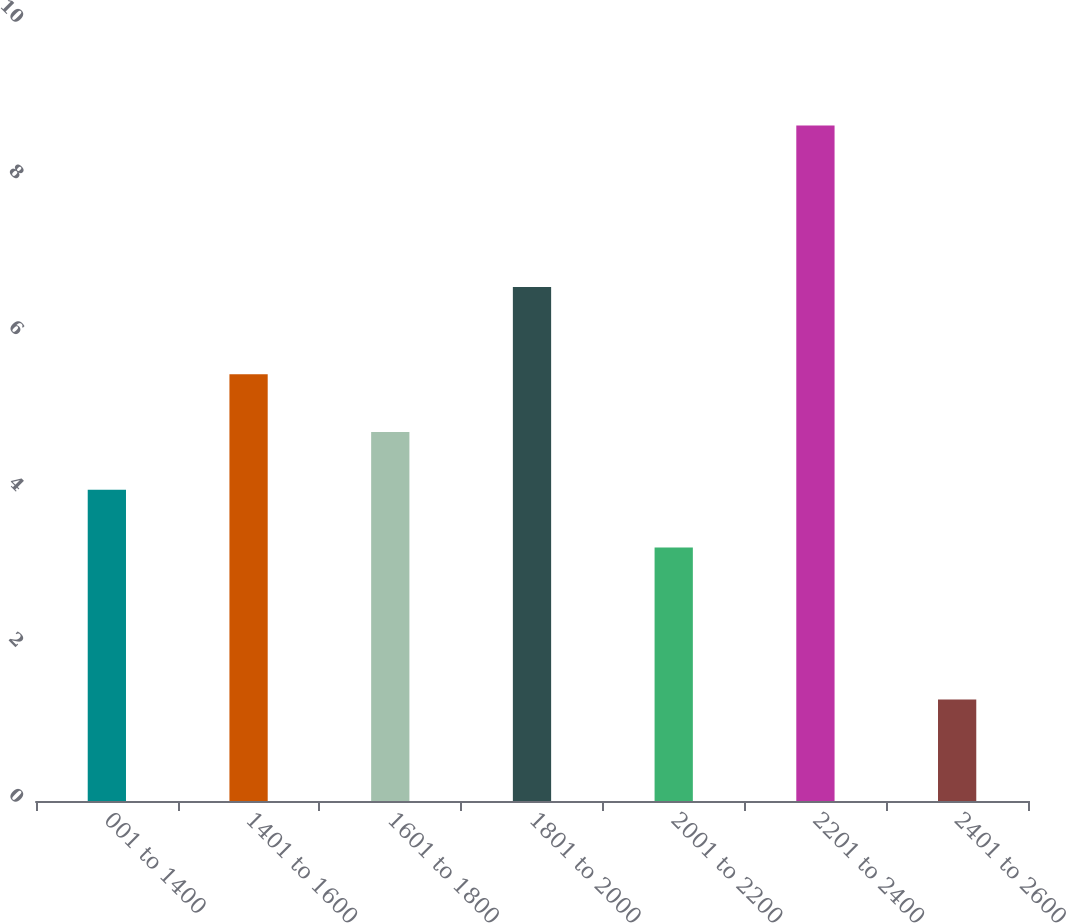Convert chart. <chart><loc_0><loc_0><loc_500><loc_500><bar_chart><fcel>001 to 1400<fcel>1401 to 1600<fcel>1601 to 1800<fcel>1801 to 2000<fcel>2001 to 2200<fcel>2201 to 2400<fcel>2401 to 2600<nl><fcel>3.99<fcel>5.47<fcel>4.73<fcel>6.59<fcel>3.25<fcel>8.66<fcel>1.3<nl></chart> 